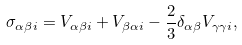Convert formula to latex. <formula><loc_0><loc_0><loc_500><loc_500>\sigma _ { \alpha \beta i } = V _ { \alpha \beta i } + V _ { \beta \alpha i } - \frac { 2 } { 3 } \delta _ { \alpha \beta } V _ { \gamma \gamma i } ,</formula> 